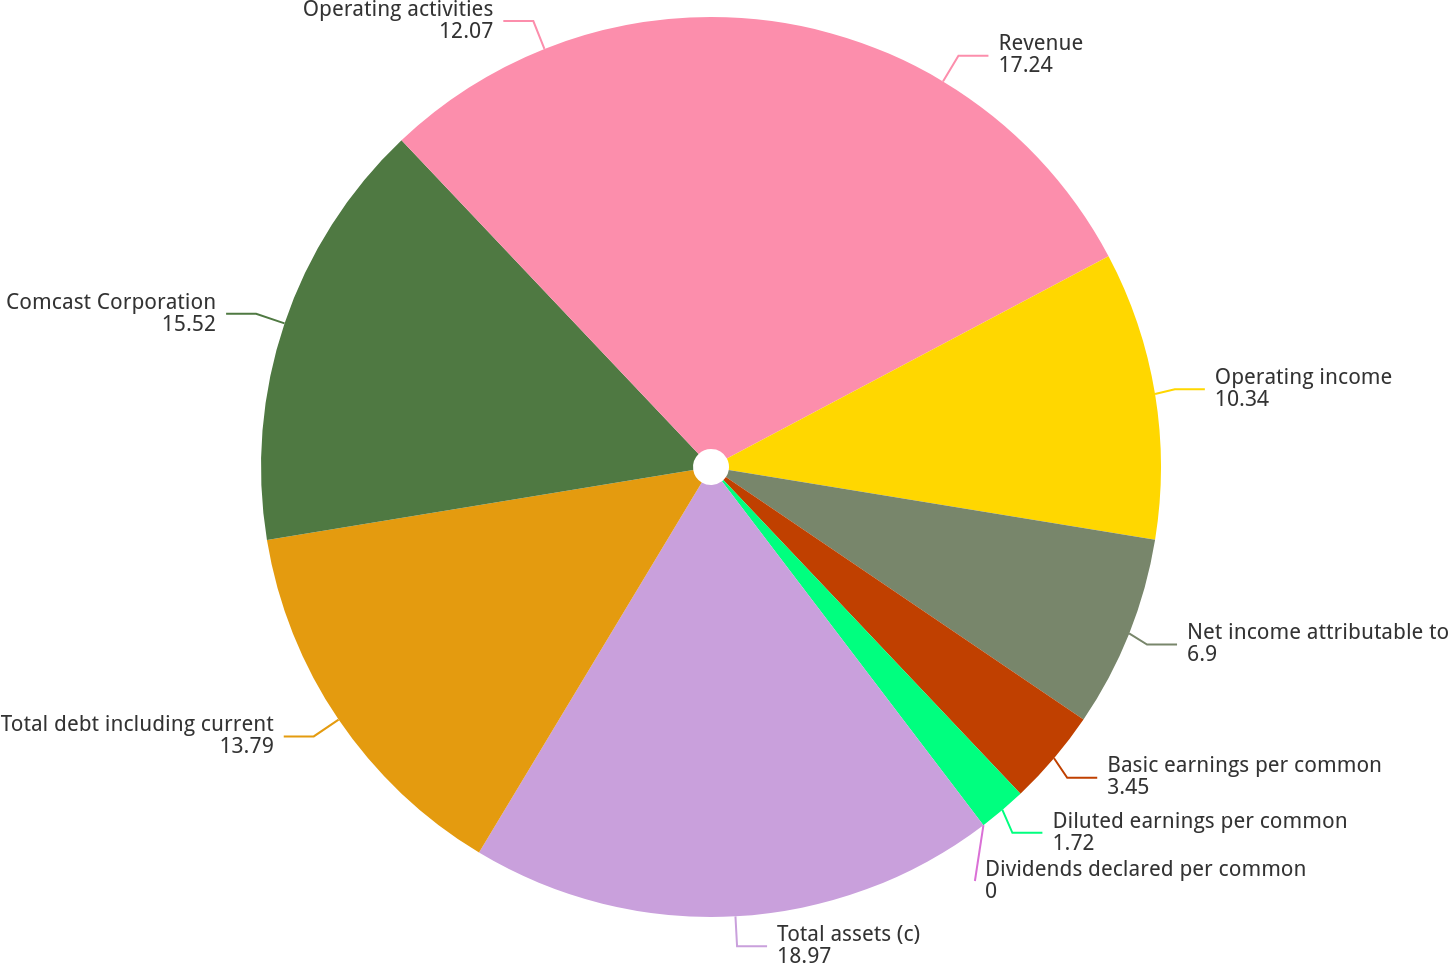<chart> <loc_0><loc_0><loc_500><loc_500><pie_chart><fcel>Revenue<fcel>Operating income<fcel>Net income attributable to<fcel>Basic earnings per common<fcel>Diluted earnings per common<fcel>Dividends declared per common<fcel>Total assets (c)<fcel>Total debt including current<fcel>Comcast Corporation<fcel>Operating activities<nl><fcel>17.24%<fcel>10.34%<fcel>6.9%<fcel>3.45%<fcel>1.72%<fcel>0.0%<fcel>18.97%<fcel>13.79%<fcel>15.52%<fcel>12.07%<nl></chart> 